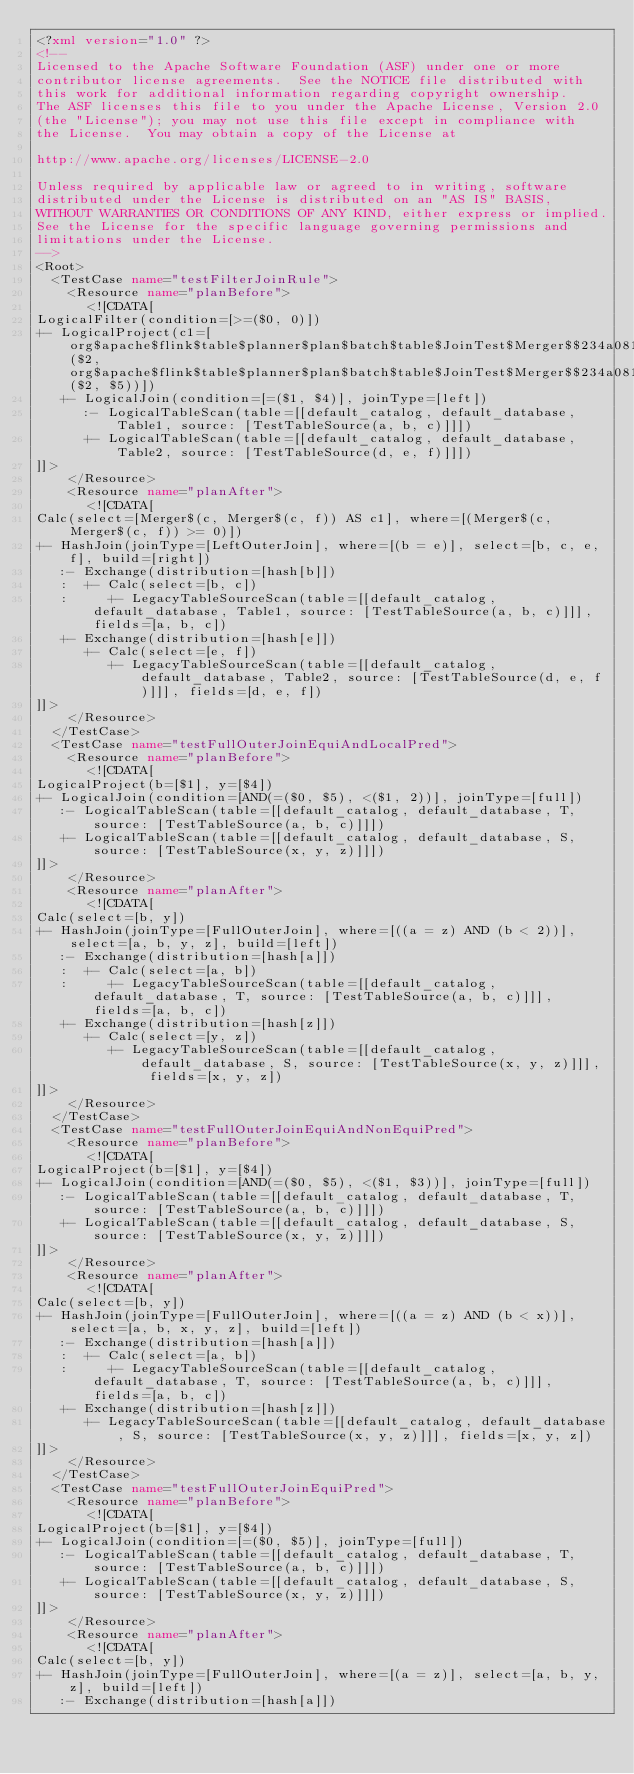Convert code to text. <code><loc_0><loc_0><loc_500><loc_500><_XML_><?xml version="1.0" ?>
<!--
Licensed to the Apache Software Foundation (ASF) under one or more
contributor license agreements.  See the NOTICE file distributed with
this work for additional information regarding copyright ownership.
The ASF licenses this file to you under the Apache License, Version 2.0
(the "License"); you may not use this file except in compliance with
the License.  You may obtain a copy of the License at

http://www.apache.org/licenses/LICENSE-2.0

Unless required by applicable law or agreed to in writing, software
distributed under the License is distributed on an "AS IS" BASIS,
WITHOUT WARRANTIES OR CONDITIONS OF ANY KIND, either express or implied.
See the License for the specific language governing permissions and
limitations under the License.
-->
<Root>
  <TestCase name="testFilterJoinRule">
    <Resource name="planBefore">
      <![CDATA[
LogicalFilter(condition=[>=($0, 0)])
+- LogicalProject(c1=[org$apache$flink$table$planner$plan$batch$table$JoinTest$Merger$$234a0810cc9eb576e09d551c1fe0de50($2, org$apache$flink$table$planner$plan$batch$table$JoinTest$Merger$$234a0810cc9eb576e09d551c1fe0de50($2, $5))])
   +- LogicalJoin(condition=[=($1, $4)], joinType=[left])
      :- LogicalTableScan(table=[[default_catalog, default_database, Table1, source: [TestTableSource(a, b, c)]]])
      +- LogicalTableScan(table=[[default_catalog, default_database, Table2, source: [TestTableSource(d, e, f)]]])
]]>
    </Resource>
    <Resource name="planAfter">
      <![CDATA[
Calc(select=[Merger$(c, Merger$(c, f)) AS c1], where=[(Merger$(c, Merger$(c, f)) >= 0)])
+- HashJoin(joinType=[LeftOuterJoin], where=[(b = e)], select=[b, c, e, f], build=[right])
   :- Exchange(distribution=[hash[b]])
   :  +- Calc(select=[b, c])
   :     +- LegacyTableSourceScan(table=[[default_catalog, default_database, Table1, source: [TestTableSource(a, b, c)]]], fields=[a, b, c])
   +- Exchange(distribution=[hash[e]])
      +- Calc(select=[e, f])
         +- LegacyTableSourceScan(table=[[default_catalog, default_database, Table2, source: [TestTableSource(d, e, f)]]], fields=[d, e, f])
]]>
    </Resource>
  </TestCase>
  <TestCase name="testFullOuterJoinEquiAndLocalPred">
    <Resource name="planBefore">
      <![CDATA[
LogicalProject(b=[$1], y=[$4])
+- LogicalJoin(condition=[AND(=($0, $5), <($1, 2))], joinType=[full])
   :- LogicalTableScan(table=[[default_catalog, default_database, T, source: [TestTableSource(a, b, c)]]])
   +- LogicalTableScan(table=[[default_catalog, default_database, S, source: [TestTableSource(x, y, z)]]])
]]>
    </Resource>
    <Resource name="planAfter">
      <![CDATA[
Calc(select=[b, y])
+- HashJoin(joinType=[FullOuterJoin], where=[((a = z) AND (b < 2))], select=[a, b, y, z], build=[left])
   :- Exchange(distribution=[hash[a]])
   :  +- Calc(select=[a, b])
   :     +- LegacyTableSourceScan(table=[[default_catalog, default_database, T, source: [TestTableSource(a, b, c)]]], fields=[a, b, c])
   +- Exchange(distribution=[hash[z]])
      +- Calc(select=[y, z])
         +- LegacyTableSourceScan(table=[[default_catalog, default_database, S, source: [TestTableSource(x, y, z)]]], fields=[x, y, z])
]]>
    </Resource>
  </TestCase>
  <TestCase name="testFullOuterJoinEquiAndNonEquiPred">
    <Resource name="planBefore">
      <![CDATA[
LogicalProject(b=[$1], y=[$4])
+- LogicalJoin(condition=[AND(=($0, $5), <($1, $3))], joinType=[full])
   :- LogicalTableScan(table=[[default_catalog, default_database, T, source: [TestTableSource(a, b, c)]]])
   +- LogicalTableScan(table=[[default_catalog, default_database, S, source: [TestTableSource(x, y, z)]]])
]]>
    </Resource>
    <Resource name="planAfter">
      <![CDATA[
Calc(select=[b, y])
+- HashJoin(joinType=[FullOuterJoin], where=[((a = z) AND (b < x))], select=[a, b, x, y, z], build=[left])
   :- Exchange(distribution=[hash[a]])
   :  +- Calc(select=[a, b])
   :     +- LegacyTableSourceScan(table=[[default_catalog, default_database, T, source: [TestTableSource(a, b, c)]]], fields=[a, b, c])
   +- Exchange(distribution=[hash[z]])
      +- LegacyTableSourceScan(table=[[default_catalog, default_database, S, source: [TestTableSource(x, y, z)]]], fields=[x, y, z])
]]>
    </Resource>
  </TestCase>
  <TestCase name="testFullOuterJoinEquiPred">
    <Resource name="planBefore">
      <![CDATA[
LogicalProject(b=[$1], y=[$4])
+- LogicalJoin(condition=[=($0, $5)], joinType=[full])
   :- LogicalTableScan(table=[[default_catalog, default_database, T, source: [TestTableSource(a, b, c)]]])
   +- LogicalTableScan(table=[[default_catalog, default_database, S, source: [TestTableSource(x, y, z)]]])
]]>
    </Resource>
    <Resource name="planAfter">
      <![CDATA[
Calc(select=[b, y])
+- HashJoin(joinType=[FullOuterJoin], where=[(a = z)], select=[a, b, y, z], build=[left])
   :- Exchange(distribution=[hash[a]])</code> 